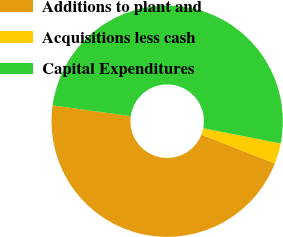<chart> <loc_0><loc_0><loc_500><loc_500><pie_chart><fcel>Additions to plant and<fcel>Acquisitions less cash<fcel>Capital Expenditures<nl><fcel>46.24%<fcel>2.86%<fcel>50.9%<nl></chart> 